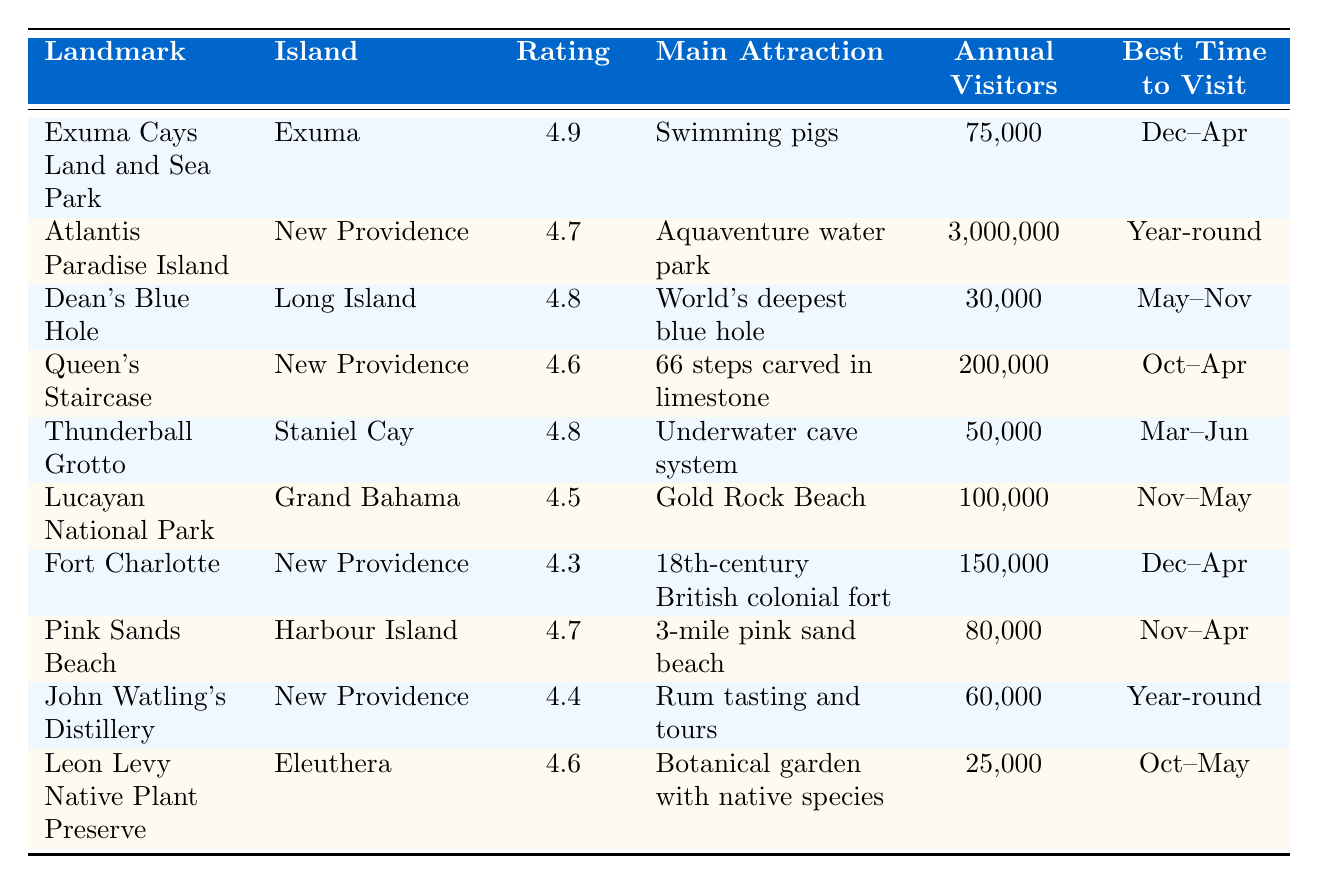What's the highest visitor rating among the landmarks? The table shows the visitor ratings for each landmark, and the highest rating is listed as 4.9 for Exuma Cays Land and Sea Park.
Answer: 4.9 How many annual visitors does Atlantis Paradise Island receive? The table indicates that Atlantis Paradise Island has an annual visitor count of 3,000,000.
Answer: 3,000,000 Which Bahamian landmark is famous for swimming pigs? According to the table, the landmark known for swimming pigs is the Exuma Cays Land and Sea Park.
Answer: Exuma Cays Land and Sea Park What is the difference in visitor ratings between Thunderball Grotto and Dean's Blue Hole? Thunderball Grotto has a rating of 4.8, and Dean's Blue Hole also has a rating of 4.8. The difference is 4.8 - 4.8 = 0.
Answer: 0 Which landmark on New Providence has the lowest visitor rating? The landmarks on New Providence shown are Atlantis Paradise Island (4.7), Queen's Staircase (4.6), Fort Charlotte (4.3), and John Watling's Distillery (4.4). The lowest among these is Fort Charlotte with 4.3.
Answer: Fort Charlotte Is there a landmark established in 1958? Yes, the Exuma Cays Land and Sea Park was established in 1958.
Answer: Yes What is the best time to visit Pink Sands Beach? The table states that the best time to visit Pink Sands Beach is from November to April.
Answer: November to April What is the total annual visitor count for the top three ranked landmarks? The top three landmarks are Exuma Cays Land and Sea Park (75,000), Atlantis Paradise Island (3,000,000), and Dean's Blue Hole (30,000). Summing these gives 75,000 + 3,000,000 + 30,000 = 3,105,000.
Answer: 3,105,000 How many more annual visitors does Lucayan National Park have compared to Leon Levy Native Plant Preserve? Lucayan National Park has 100,000 annual visitors and Leon Levy Native Plant Preserve has 25,000. The difference is 100,000 - 25,000 = 75,000.
Answer: 75,000 Which landmark was established the earliest? Among the listed landmarks, Queen's Staircase was established in 1793, making it the earliest.
Answer: Queen's Staircase 